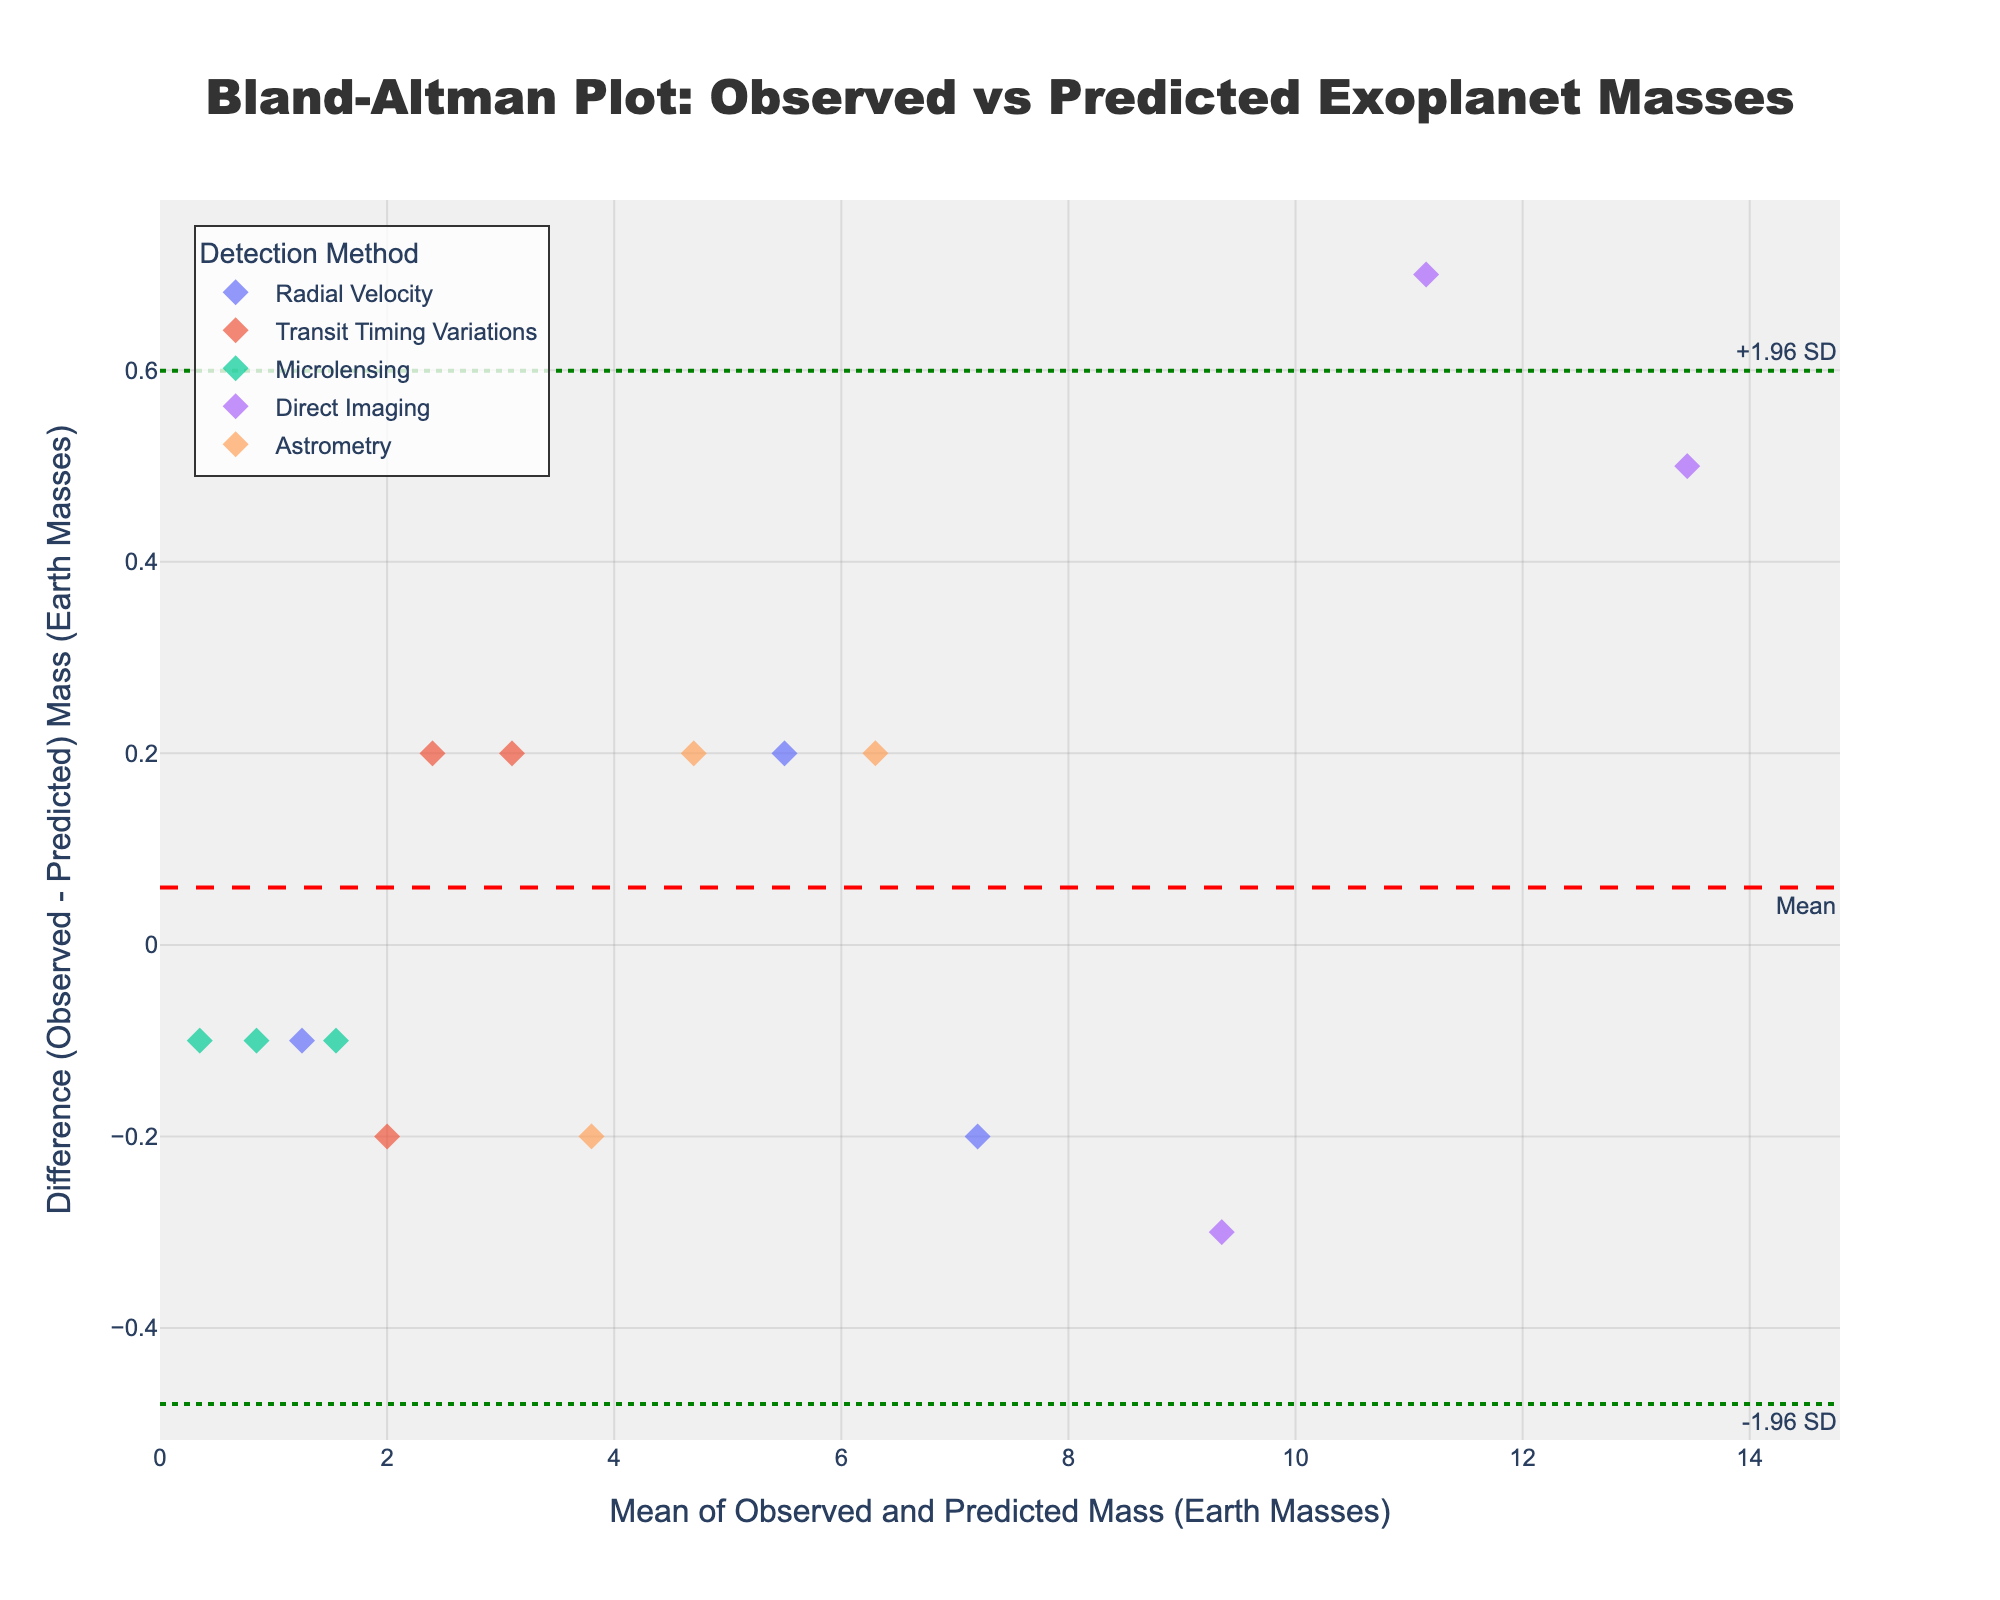How many unique detection methods are represented in the plot? Look at the legend to identify the different detection methods indicated by their labels. There are Radial Velocity, Transit Timing Variations, Microlensing, Direct Imaging, and Astrometry listed.
Answer: 5 What is the title of the plot? The title is usually at the top of the plot. Here, it reads "Bland-Altman Plot: Observed vs Predicted Exoplanet Masses".
Answer: Bland-Altman Plot: Observed vs Predicted Exoplanet Masses Which detection method has the largest difference between observed and predicted exoplanet mass? Check the y-axis (Difference) values for the points and identify the method with the highest value. The largest difference appears for Direct Imaging with a value closest to the upper limit.
Answer: Direct Imaging What is the range of values on the x-axis? Check the x-axis labels to identify the minimum and maximum values. The axis ranges from approximately 0 to 15.
Answer: 0 to 15 What is the mean difference (Observed - Predicted) exoplanet mass across all detection methods? An annotation marks the mean difference with a horizontal dashed red line. The mean difference is at the value where this line intersects the y-axis.
Answer: Approximately -0.1 (as visually indicated) Which detection method has points closest to the mean difference line? Examine points clustered around the mean difference horizontal line and identify the detection method from the legend. Radial Velocity points appear closest to the mean difference line.
Answer: Radial Velocity Are there any methods where the observed masses are consistently higher than the predicted masses? Look for points where the difference (y-axis) is mostly positive. Direct Imaging has several points above the mean difference line indicating consistently higher observed masses.
Answer: Direct Imaging Which method shows the smallest variability in the difference between observed and predicted exoplanet masses? Identify the method with points closest to each other along the y-axis. Microlensing points show little spread around the mean difference, indicating low variability.
Answer: Microlensing What are the upper and lower limits of agreement for the differences? Horizontal green dotted lines indicate the limits of agreement. The upper and lower limit values are where these lines intersect the y-axis.
Answer: Approximately 1.5 and -1.7 